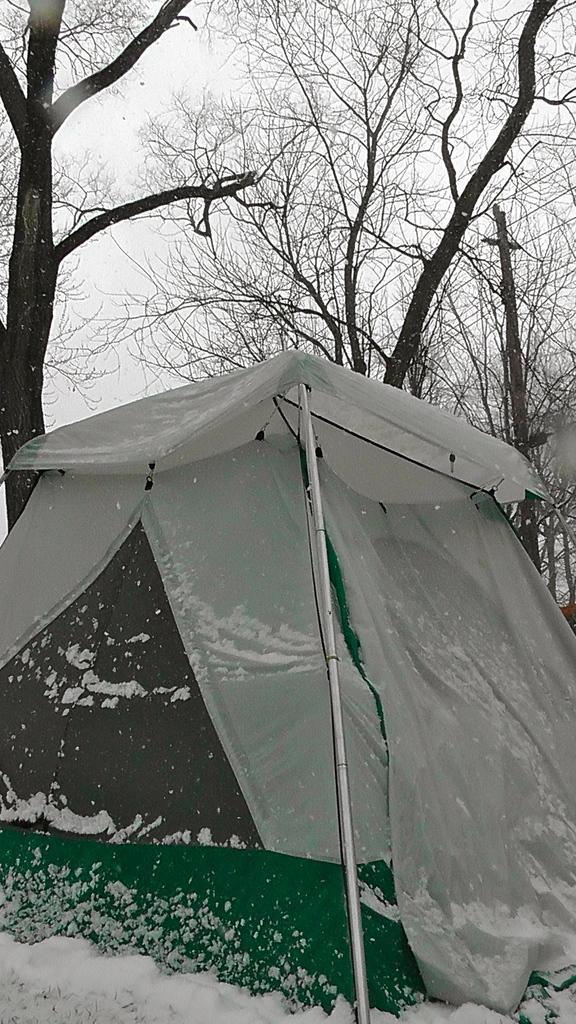Can you describe this image briefly? In the center of the image there is a tent. In the background we can see trees and sky. At the bottom there is a snow. 